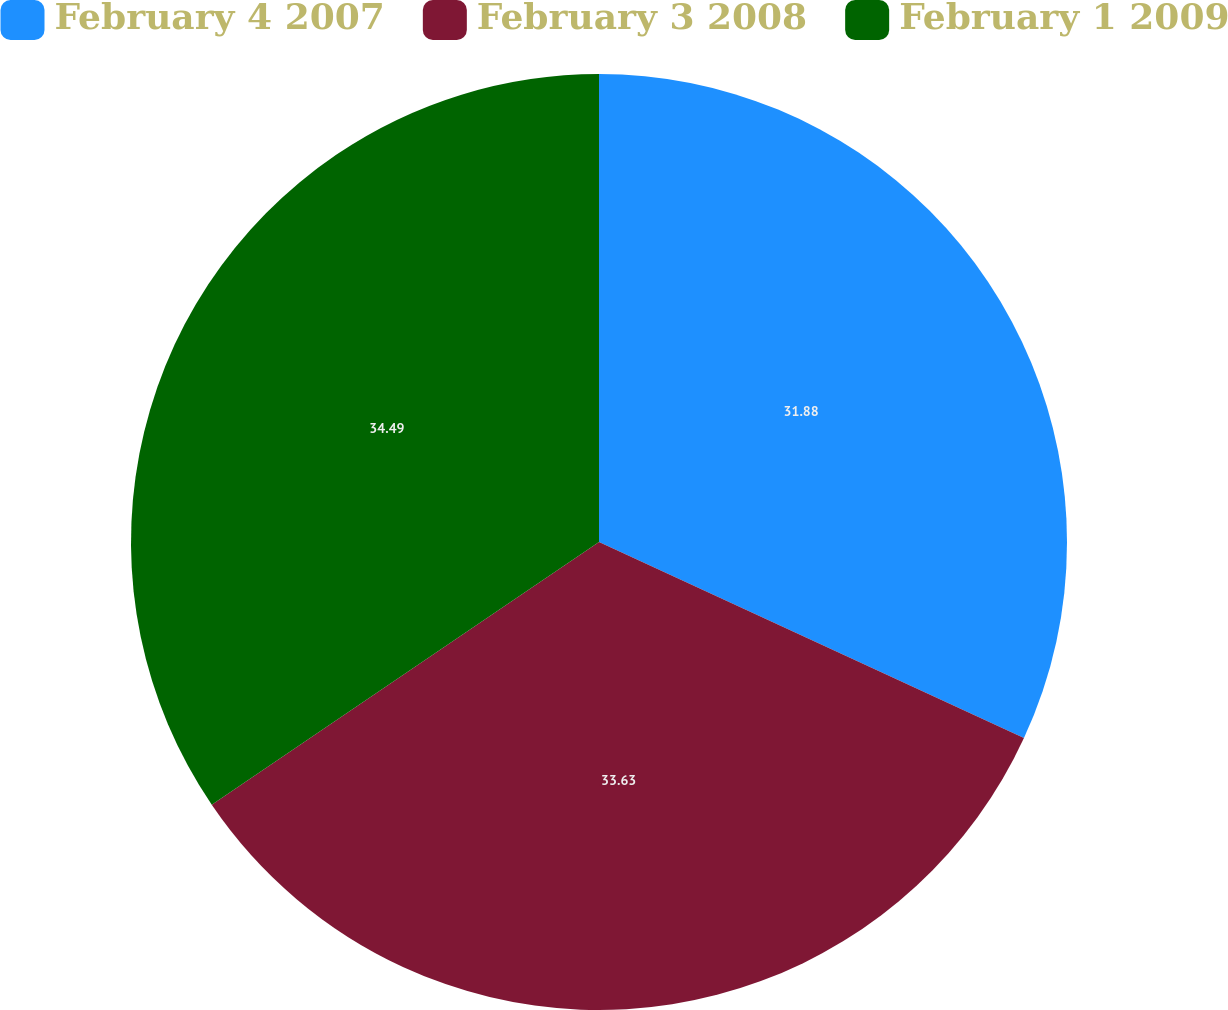Convert chart. <chart><loc_0><loc_0><loc_500><loc_500><pie_chart><fcel>February 4 2007<fcel>February 3 2008<fcel>February 1 2009<nl><fcel>31.88%<fcel>33.63%<fcel>34.49%<nl></chart> 